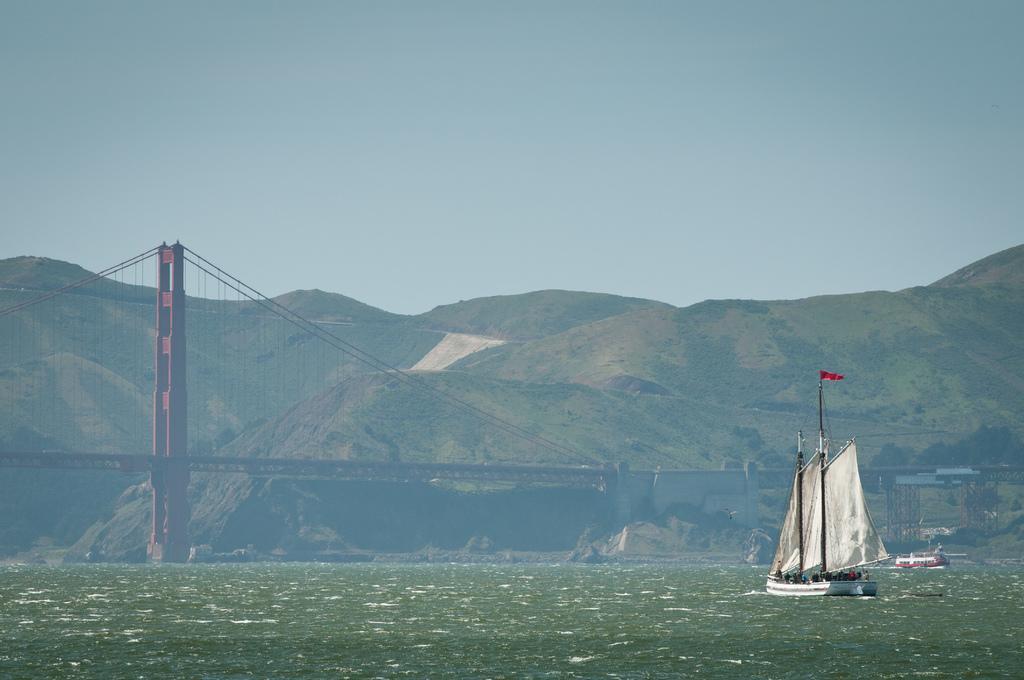Describe this image in one or two sentences. In the image we can see there are boats in the water. We can even see the bridge, hills and the sky. 